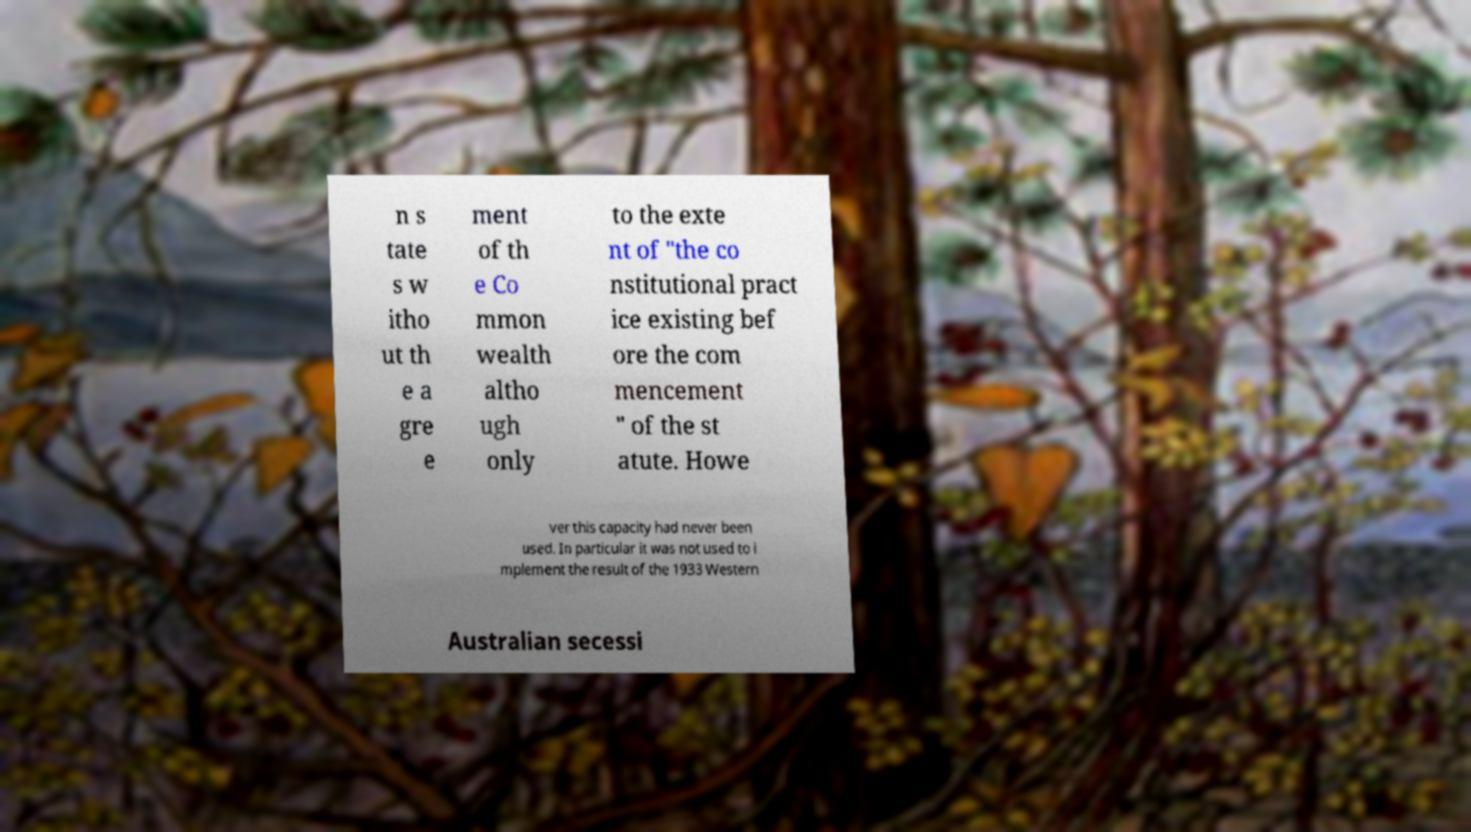Could you assist in decoding the text presented in this image and type it out clearly? n s tate s w itho ut th e a gre e ment of th e Co mmon wealth altho ugh only to the exte nt of "the co nstitutional pract ice existing bef ore the com mencement " of the st atute. Howe ver this capacity had never been used. In particular it was not used to i mplement the result of the 1933 Western Australian secessi 